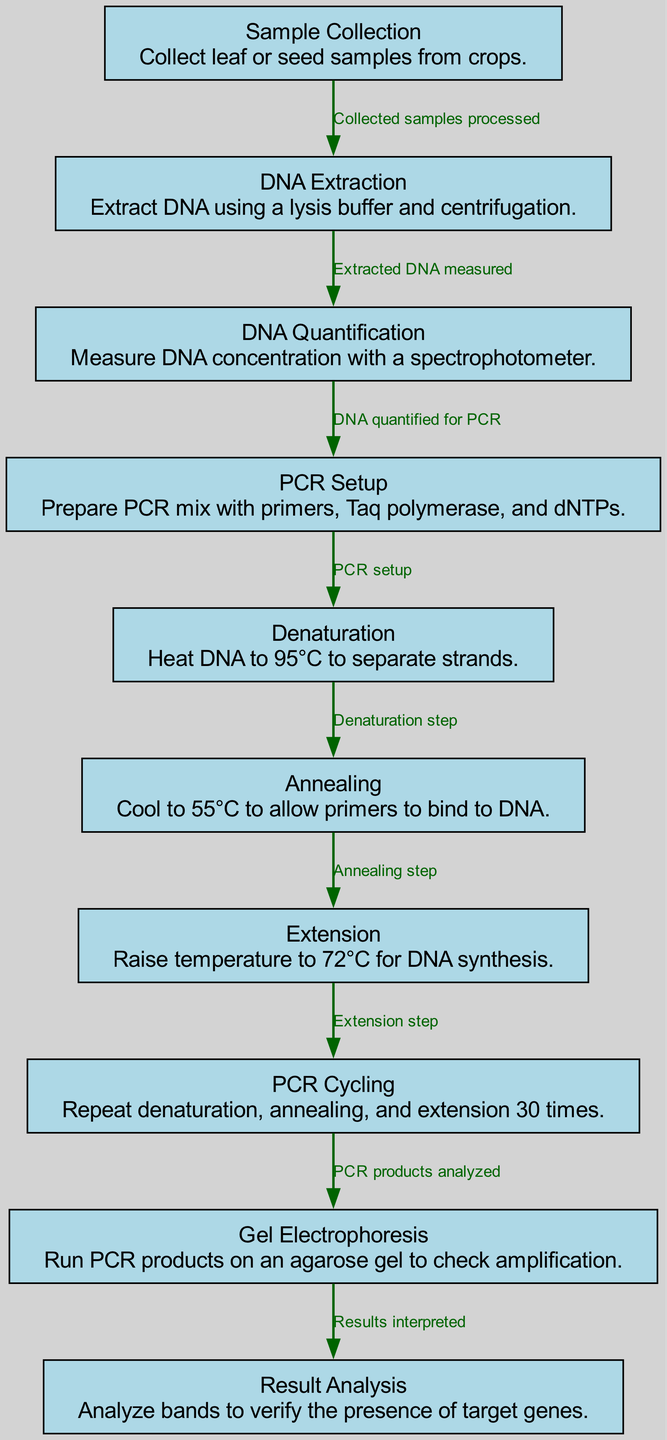What is the first step in the PCR amplification process? The first node in the diagram is "Sample Collection," which details the collection of leaf or seed samples. This indicates that Sample Collection is the initial step in the process.
Answer: Sample Collection What is performed after DNA extraction? After "DNA Extraction," the next node is "DNA Quantification," which involves measuring the concentration of extracted DNA using a spectrophotometer. This establishes that DNA Quantification follows DNA Extraction.
Answer: DNA Quantification How many times is PCR cycling repeated? The "PCR Cycling" node states that the process is repeated 30 times, indicating the number of cycles necessary for amplification. This means the PCR Cycling is performed 30 times in the overall process.
Answer: 30 What happens during the extension step of PCR? The node labeled "Extension" specifies raising the temperature to 72°C for DNA synthesis. This clarifies the function of the extension step in the PCR process.
Answer: DNA synthesis What is the final node in the diagram? The diagram concludes with the node "Result Analysis," which indicates that this is the last step, where the bands are analyzed to verify the presence of target genes. This helps identify Result Analysis as the endpoint of the process.
Answer: Result Analysis What is used to check the PCR products? The "Gel Electrophoresis" node explains that this step involves running PCR products on an agarose gel, highlighting its role in verifying amplification through a visual check.
Answer: Agarose gel What relationship is indicated between DNA extraction and quantification? The edge connecting "DNA Extraction" to "DNA Quantification" is labeled "Extracted DNA measured," which shows that the extraction step is directly associated with the quantification of extracted DNA. This establishes a clear causative link between the two.
Answer: Extracted DNA measured Which step comes immediately after denaturation? Following "Denaturation," the next step specified in the diagram is "Annealing," which details cooling the temperature to allow primer binding to the DNA strands. This connects the two consecutive steps in the PCR process.
Answer: Annealing 